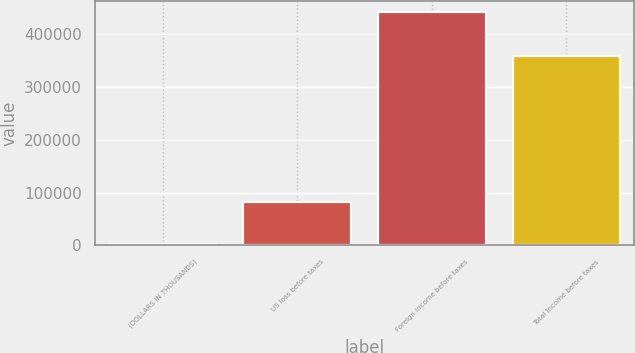Convert chart. <chart><loc_0><loc_0><loc_500><loc_500><bar_chart><fcel>(DOLLARS IN THOUSANDS)<fcel>US loss before taxes<fcel>Foreign income before taxes<fcel>Total income before taxes<nl><fcel>2010<fcel>82112<fcel>441705<fcel>359593<nl></chart> 